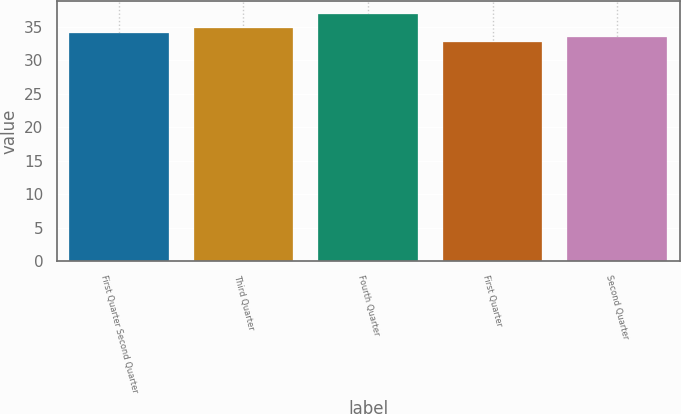Convert chart. <chart><loc_0><loc_0><loc_500><loc_500><bar_chart><fcel>First Quarter Second Quarter<fcel>Third Quarter<fcel>Fourth Quarter<fcel>First Quarter<fcel>Second Quarter<nl><fcel>34.08<fcel>34.8<fcel>36.97<fcel>32.79<fcel>33.54<nl></chart> 